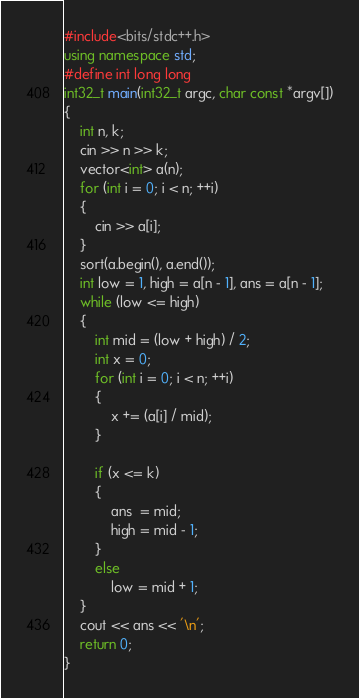Convert code to text. <code><loc_0><loc_0><loc_500><loc_500><_C++_>#include<bits/stdc++.h>
using namespace std;
#define int long long
int32_t main(int32_t argc, char const *argv[])
{
	int n, k;
	cin >> n >> k;
	vector<int> a(n);
	for (int i = 0; i < n; ++i)
	{
		cin >> a[i];
	}
	sort(a.begin(), a.end());
	int low = 1, high = a[n - 1], ans = a[n - 1];
	while (low <= high)
	{
		int mid = (low + high) / 2;
		int x = 0;
		for (int i = 0; i < n; ++i)
		{
			x += (a[i] / mid);
		}
		
		if (x <= k)
		{
			ans  = mid;
			high = mid - 1;
		}
		else
			low = mid + 1;
	}
	cout << ans << '\n';
	return 0;
}</code> 